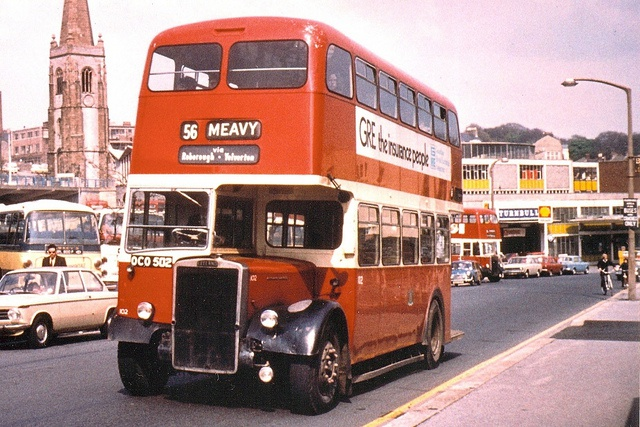Describe the objects in this image and their specific colors. I can see bus in white, black, red, and gray tones, car in white, black, lightpink, and gray tones, bus in white, ivory, gray, and darkgray tones, bus in white, red, lightpink, and brown tones, and bus in white, lightpink, gray, and brown tones in this image. 